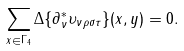<formula> <loc_0><loc_0><loc_500><loc_500>\sum _ { x \in \Gamma _ { 4 } } \Delta \{ \partial _ { \nu } ^ { \ast } \upsilon _ { \nu \rho \sigma \tau } \} ( x , y ) = 0 .</formula> 